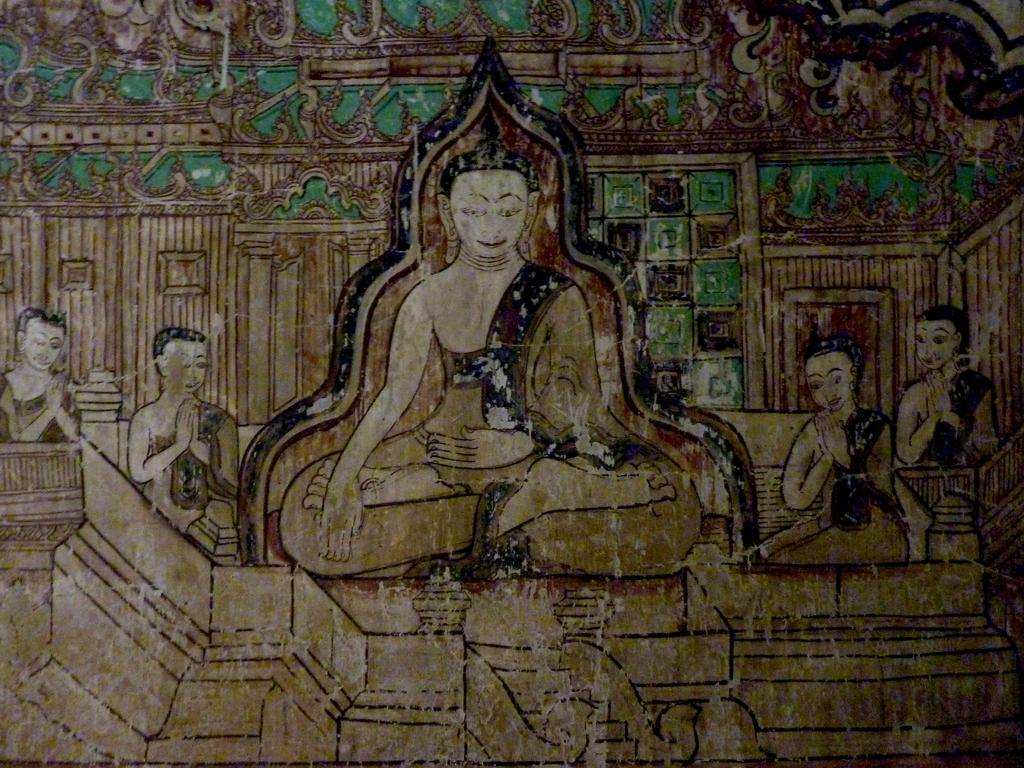What is the main subject of the image? The main subject of the image is a painting. Can you describe the content of the painting? The painting contains people and objects. How many feet are visible in the painting? There is no information about feet in the image, as it only contains a painting with people and objects. 